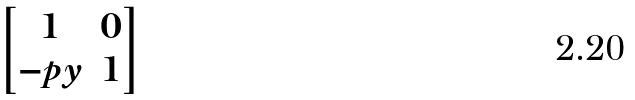<formula> <loc_0><loc_0><loc_500><loc_500>\begin{bmatrix} 1 & 0 \\ - p y & 1 \end{bmatrix}</formula> 